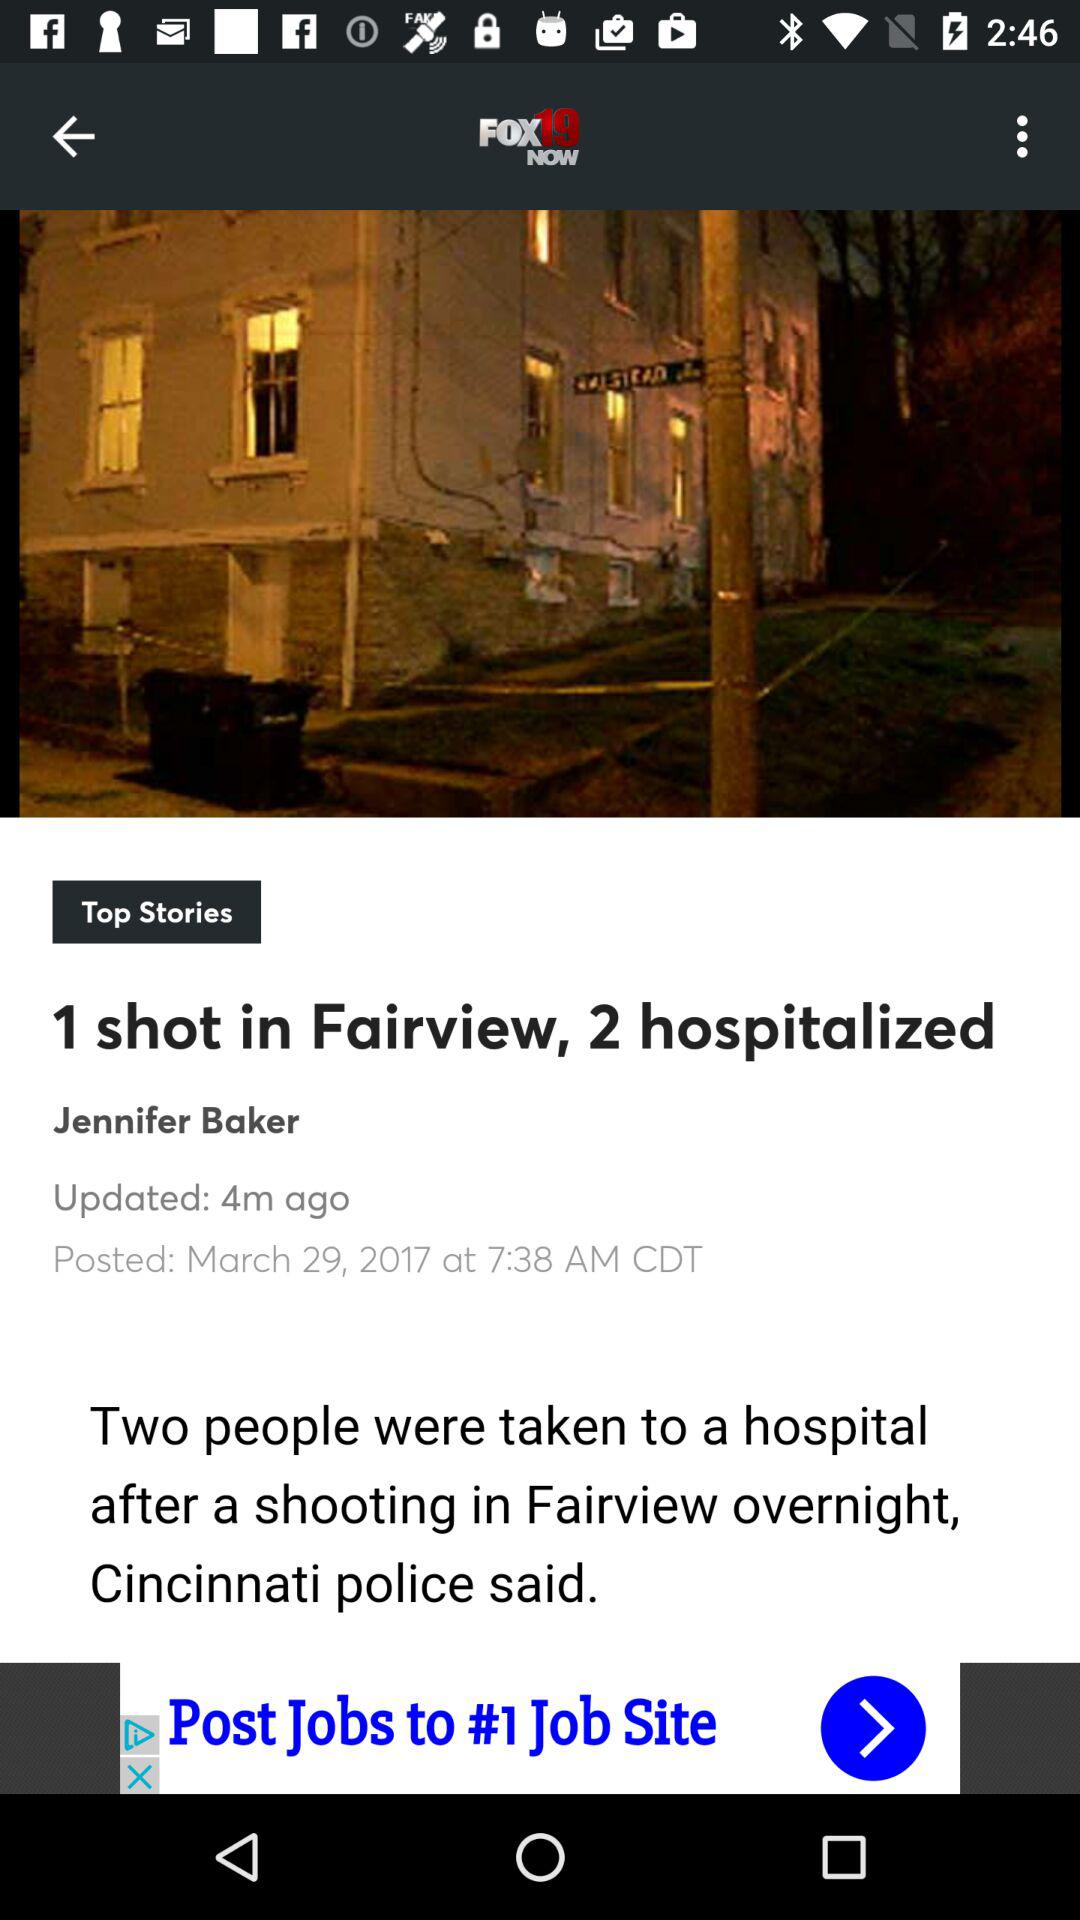What is the posted date? The posted date is March 29, 2017. 